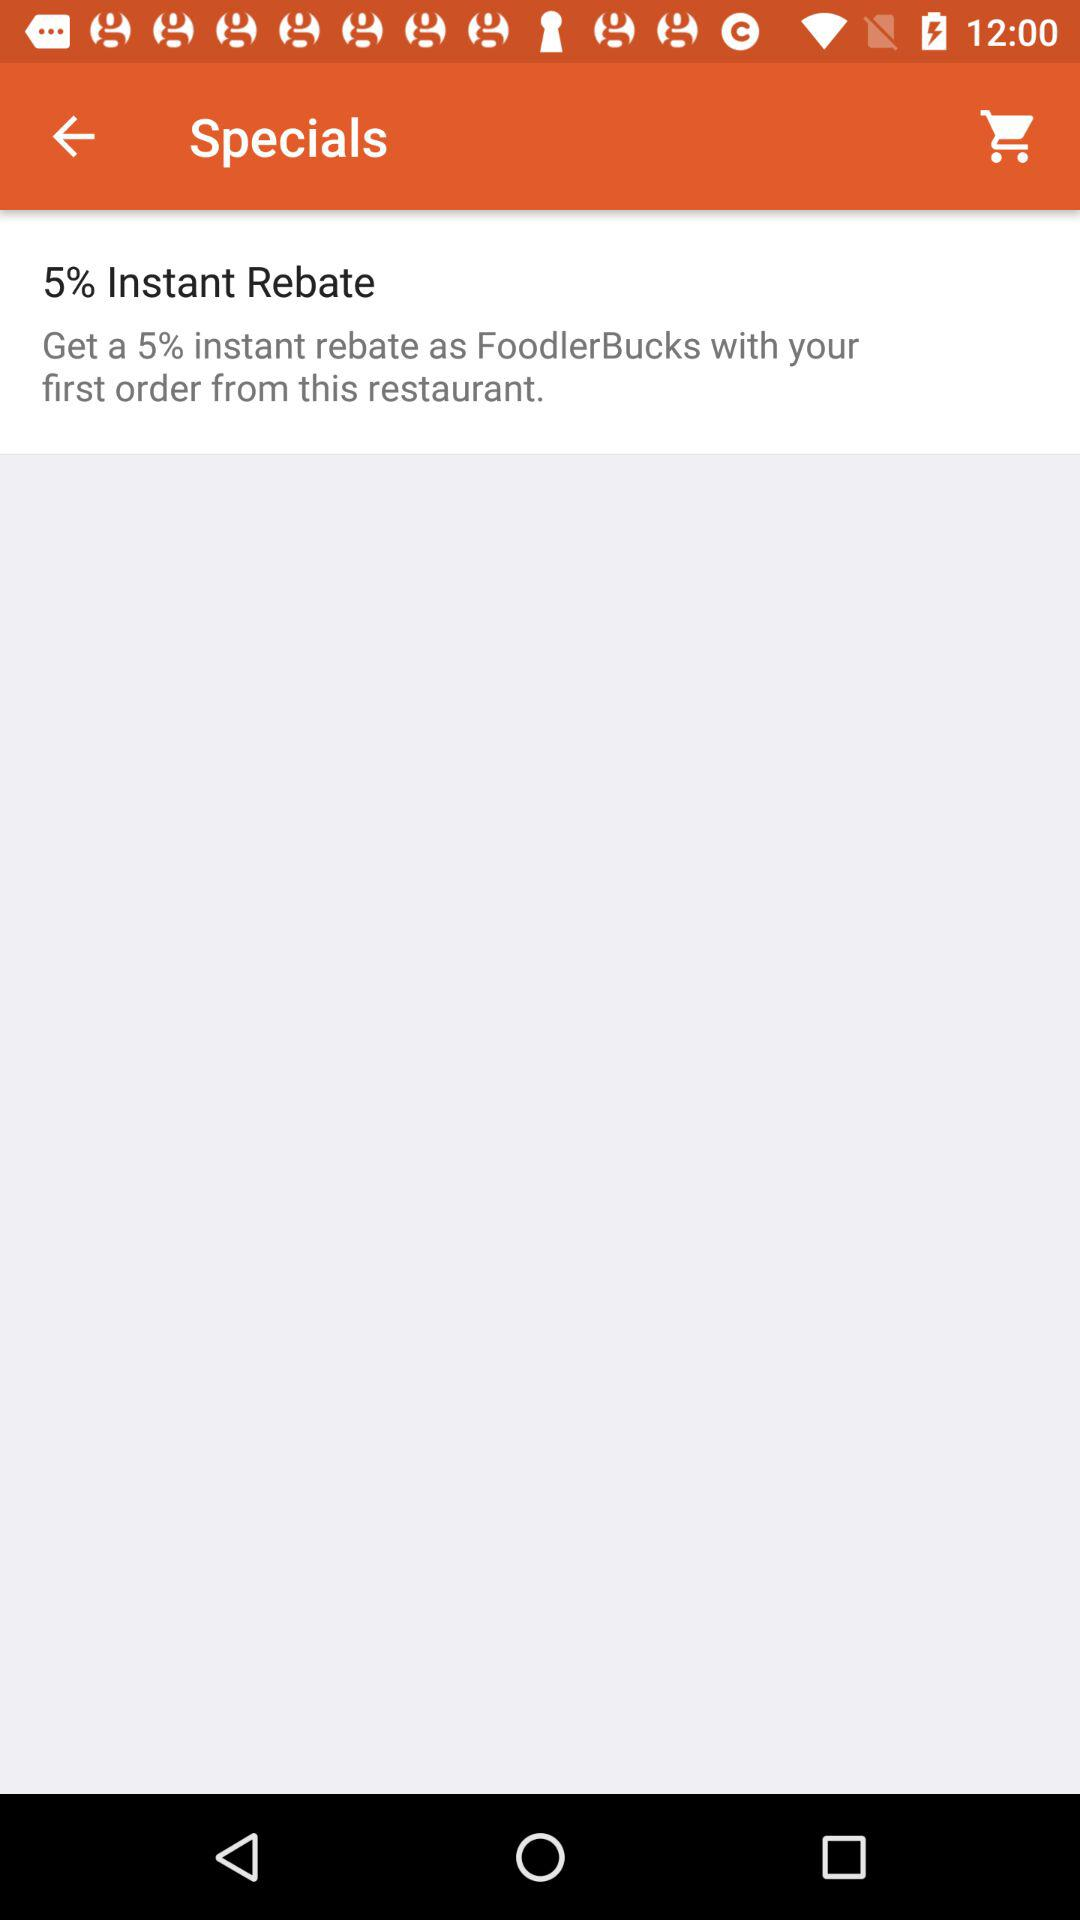What is the percentage of the instant rebate? The percentage of the instant rebate is 5. 